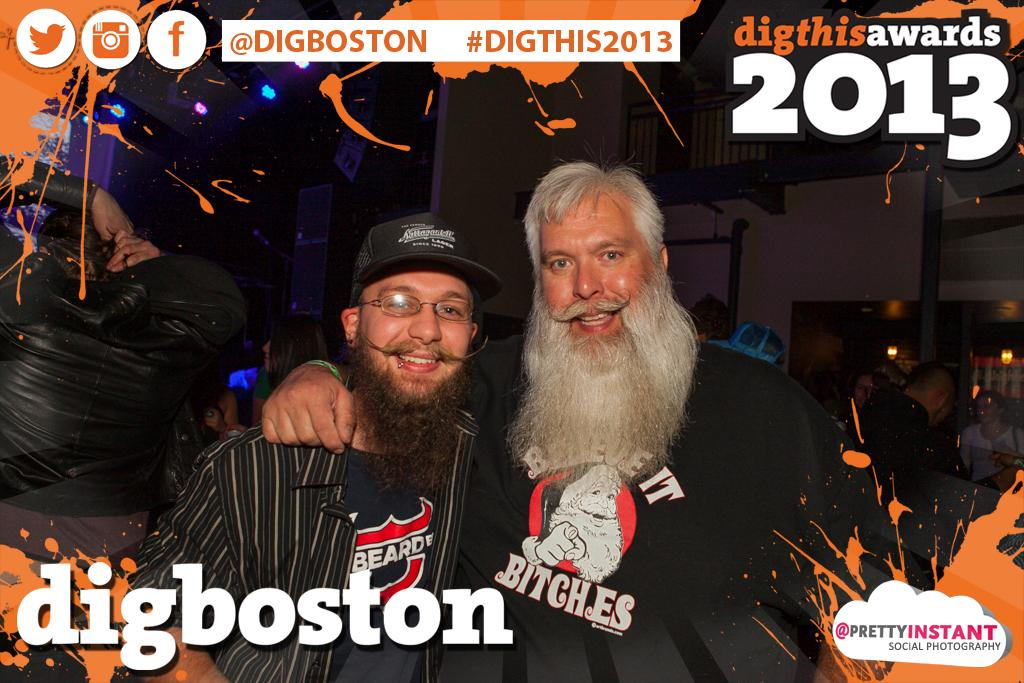How many people are in the image? There is a group of people in the image, but the exact number is not specified. What are the people in the image doing? The people are standing in the image. What is located behind the people? There is a wall behind the people in the image. What can be seen in terms of illumination in the image? There are lights visible in the image. What type of cheese is being sold at the market in the image? There is no market or cheese present in the image; it features a group of people standing in front of a wall with lights visible. How many geese are visible in the image? There are no geese present in the image. 